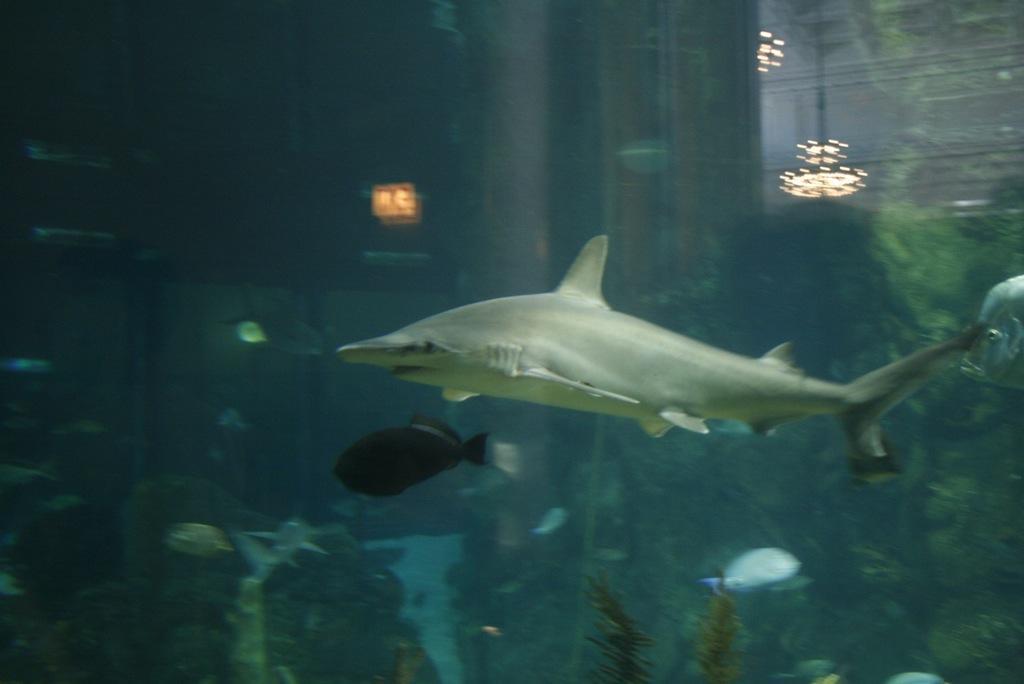Can you describe this image briefly? In this picture we can see a shark and some fishes, we can see underwater environment here. 